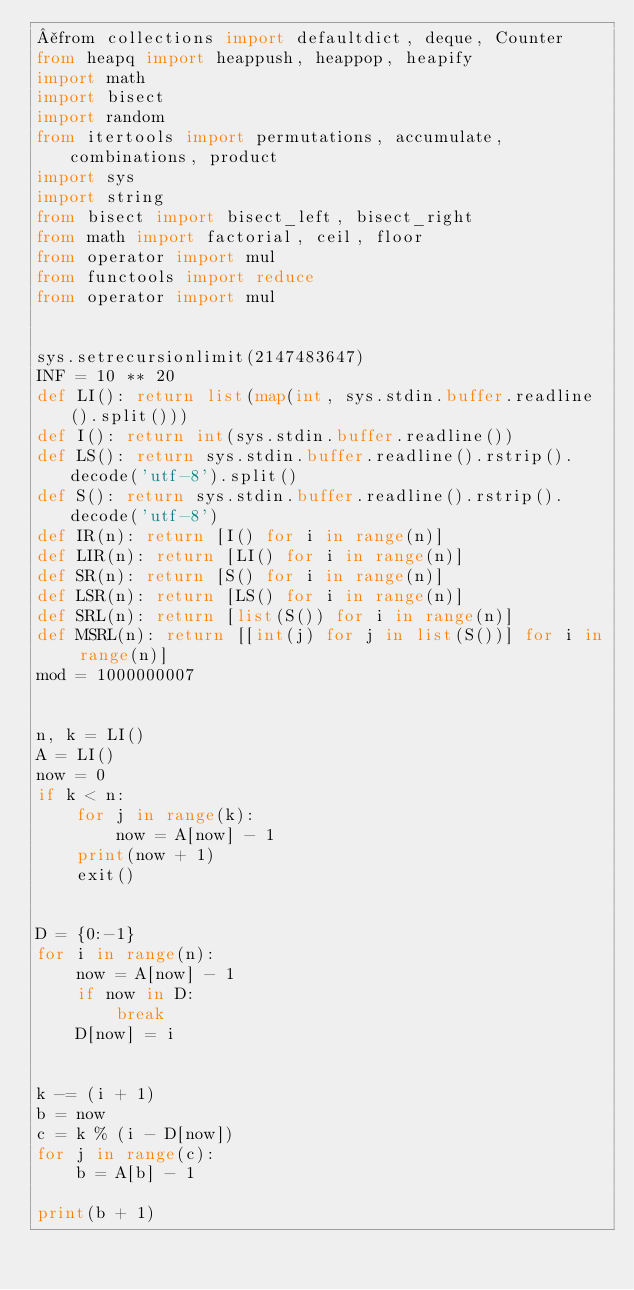<code> <loc_0><loc_0><loc_500><loc_500><_Python_>¥from collections import defaultdict, deque, Counter
from heapq import heappush, heappop, heapify
import math
import bisect
import random
from itertools import permutations, accumulate, combinations, product
import sys
import string
from bisect import bisect_left, bisect_right
from math import factorial, ceil, floor
from operator import mul
from functools import reduce
from operator import mul


sys.setrecursionlimit(2147483647)
INF = 10 ** 20
def LI(): return list(map(int, sys.stdin.buffer.readline().split()))
def I(): return int(sys.stdin.buffer.readline())
def LS(): return sys.stdin.buffer.readline().rstrip().decode('utf-8').split()
def S(): return sys.stdin.buffer.readline().rstrip().decode('utf-8')
def IR(n): return [I() for i in range(n)]
def LIR(n): return [LI() for i in range(n)]
def SR(n): return [S() for i in range(n)]
def LSR(n): return [LS() for i in range(n)]
def SRL(n): return [list(S()) for i in range(n)]
def MSRL(n): return [[int(j) for j in list(S())] for i in range(n)]
mod = 1000000007


n, k = LI()
A = LI()
now = 0
if k < n:
    for j in range(k):
        now = A[now] - 1
    print(now + 1)
    exit()


D = {0:-1}
for i in range(n):
    now = A[now] - 1
    if now in D:
        break
    D[now] = i


k -= (i + 1)
b = now
c = k % (i - D[now])
for j in range(c):
    b = A[b] - 1

print(b + 1)






</code> 